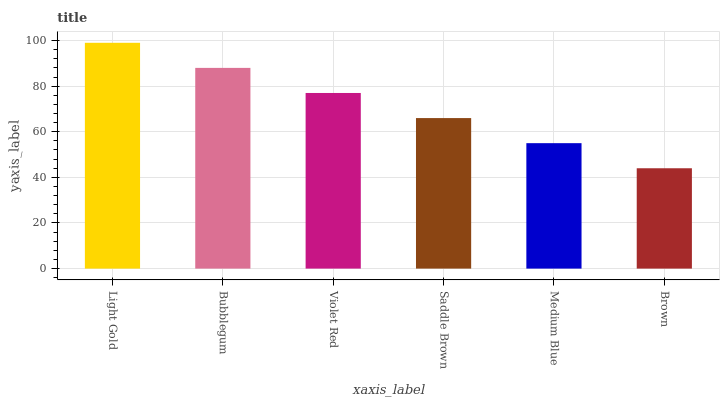Is Brown the minimum?
Answer yes or no. Yes. Is Light Gold the maximum?
Answer yes or no. Yes. Is Bubblegum the minimum?
Answer yes or no. No. Is Bubblegum the maximum?
Answer yes or no. No. Is Light Gold greater than Bubblegum?
Answer yes or no. Yes. Is Bubblegum less than Light Gold?
Answer yes or no. Yes. Is Bubblegum greater than Light Gold?
Answer yes or no. No. Is Light Gold less than Bubblegum?
Answer yes or no. No. Is Violet Red the high median?
Answer yes or no. Yes. Is Saddle Brown the low median?
Answer yes or no. Yes. Is Bubblegum the high median?
Answer yes or no. No. Is Violet Red the low median?
Answer yes or no. No. 